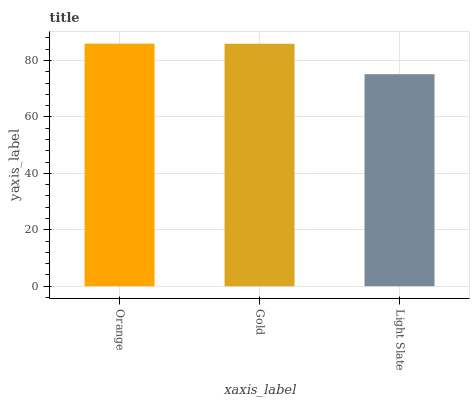Is Light Slate the minimum?
Answer yes or no. Yes. Is Orange the maximum?
Answer yes or no. Yes. Is Gold the minimum?
Answer yes or no. No. Is Gold the maximum?
Answer yes or no. No. Is Orange greater than Gold?
Answer yes or no. Yes. Is Gold less than Orange?
Answer yes or no. Yes. Is Gold greater than Orange?
Answer yes or no. No. Is Orange less than Gold?
Answer yes or no. No. Is Gold the high median?
Answer yes or no. Yes. Is Gold the low median?
Answer yes or no. Yes. Is Orange the high median?
Answer yes or no. No. Is Light Slate the low median?
Answer yes or no. No. 